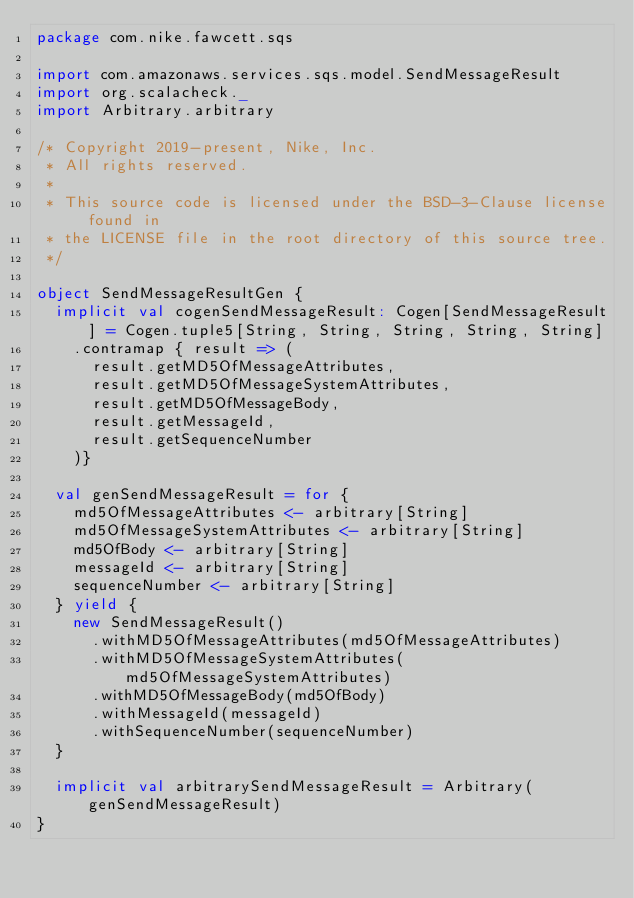Convert code to text. <code><loc_0><loc_0><loc_500><loc_500><_Scala_>package com.nike.fawcett.sqs

import com.amazonaws.services.sqs.model.SendMessageResult
import org.scalacheck._
import Arbitrary.arbitrary

/* Copyright 2019-present, Nike, Inc.
 * All rights reserved.
 *
 * This source code is licensed under the BSD-3-Clause license found in
 * the LICENSE file in the root directory of this source tree.
 */

object SendMessageResultGen {
  implicit val cogenSendMessageResult: Cogen[SendMessageResult] = Cogen.tuple5[String, String, String, String, String]
    .contramap { result => (
      result.getMD5OfMessageAttributes,
      result.getMD5OfMessageSystemAttributes,
      result.getMD5OfMessageBody,
      result.getMessageId,
      result.getSequenceNumber
    )}

  val genSendMessageResult = for {
    md5OfMessageAttributes <- arbitrary[String]
    md5OfMessageSystemAttributes <- arbitrary[String]
    md5OfBody <- arbitrary[String]
    messageId <- arbitrary[String]
    sequenceNumber <- arbitrary[String]
  } yield {
    new SendMessageResult()
      .withMD5OfMessageAttributes(md5OfMessageAttributes)
      .withMD5OfMessageSystemAttributes(md5OfMessageSystemAttributes)
      .withMD5OfMessageBody(md5OfBody)
      .withMessageId(messageId)
      .withSequenceNumber(sequenceNumber)
  }

  implicit val arbitrarySendMessageResult = Arbitrary(genSendMessageResult)
}
</code> 